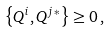Convert formula to latex. <formula><loc_0><loc_0><loc_500><loc_500>\left \{ Q ^ { i } , Q ^ { j \, * } \right \} \geq 0 \, ,</formula> 